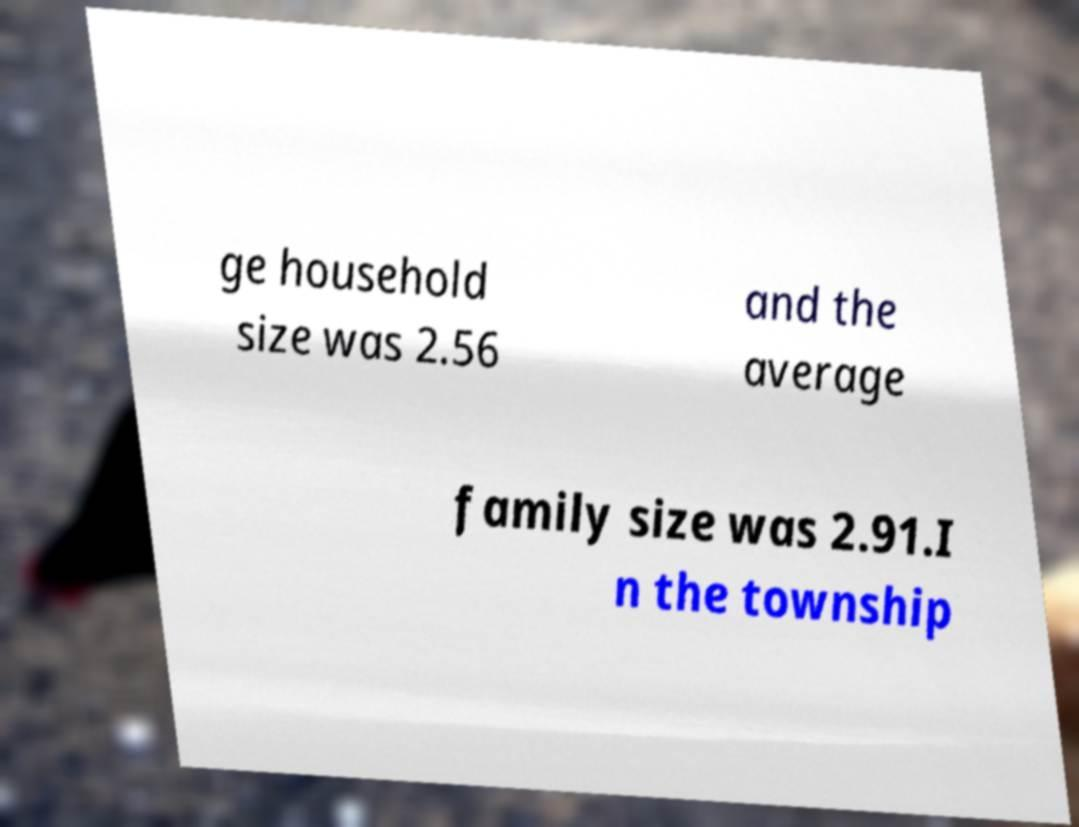For documentation purposes, I need the text within this image transcribed. Could you provide that? ge household size was 2.56 and the average family size was 2.91.I n the township 